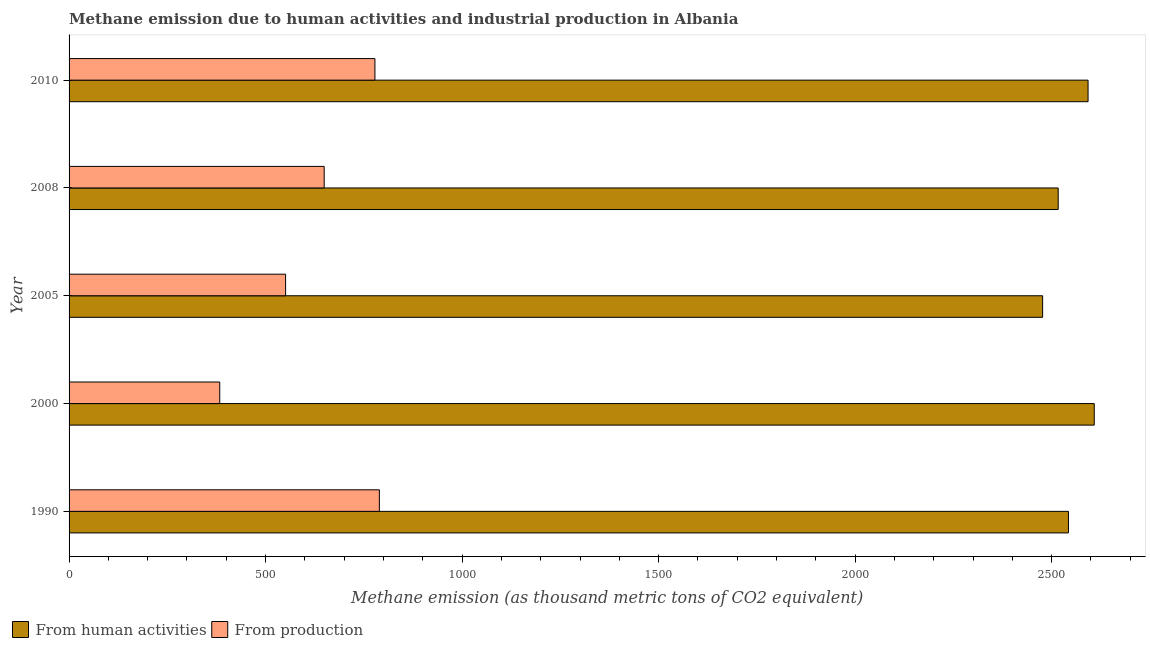How many groups of bars are there?
Give a very brief answer. 5. Are the number of bars on each tick of the Y-axis equal?
Ensure brevity in your answer.  Yes. What is the label of the 4th group of bars from the top?
Keep it short and to the point. 2000. What is the amount of emissions generated from industries in 2005?
Offer a terse response. 550.9. Across all years, what is the maximum amount of emissions from human activities?
Your answer should be very brief. 2608.4. Across all years, what is the minimum amount of emissions generated from industries?
Your response must be concise. 383.4. In which year was the amount of emissions from human activities maximum?
Make the answer very short. 2000. In which year was the amount of emissions generated from industries minimum?
Give a very brief answer. 2000. What is the total amount of emissions from human activities in the graph?
Your response must be concise. 1.27e+04. What is the difference between the amount of emissions from human activities in 2005 and that in 2010?
Provide a short and direct response. -115.6. What is the difference between the amount of emissions from human activities in 2005 and the amount of emissions generated from industries in 2010?
Make the answer very short. 1698.9. What is the average amount of emissions from human activities per year?
Ensure brevity in your answer.  2547.54. In the year 2008, what is the difference between the amount of emissions from human activities and amount of emissions generated from industries?
Your answer should be compact. 1867.6. What is the ratio of the amount of emissions from human activities in 2008 to that in 2010?
Give a very brief answer. 0.97. Is the amount of emissions generated from industries in 2005 less than that in 2008?
Your answer should be very brief. Yes. Is the difference between the amount of emissions generated from industries in 2005 and 2008 greater than the difference between the amount of emissions from human activities in 2005 and 2008?
Your answer should be compact. No. What is the difference between the highest and the second highest amount of emissions generated from industries?
Offer a very short reply. 11.3. What is the difference between the highest and the lowest amount of emissions generated from industries?
Provide a short and direct response. 406.1. In how many years, is the amount of emissions generated from industries greater than the average amount of emissions generated from industries taken over all years?
Offer a very short reply. 3. Is the sum of the amount of emissions from human activities in 2000 and 2008 greater than the maximum amount of emissions generated from industries across all years?
Your response must be concise. Yes. What does the 1st bar from the top in 2010 represents?
Your answer should be compact. From production. What does the 1st bar from the bottom in 1990 represents?
Provide a short and direct response. From human activities. Are all the bars in the graph horizontal?
Offer a terse response. Yes. What is the difference between two consecutive major ticks on the X-axis?
Give a very brief answer. 500. Are the values on the major ticks of X-axis written in scientific E-notation?
Ensure brevity in your answer.  No. How are the legend labels stacked?
Your answer should be compact. Horizontal. What is the title of the graph?
Ensure brevity in your answer.  Methane emission due to human activities and industrial production in Albania. Does "Crop" appear as one of the legend labels in the graph?
Your response must be concise. No. What is the label or title of the X-axis?
Your answer should be very brief. Methane emission (as thousand metric tons of CO2 equivalent). What is the label or title of the Y-axis?
Your response must be concise. Year. What is the Methane emission (as thousand metric tons of CO2 equivalent) in From human activities in 1990?
Provide a succinct answer. 2542.8. What is the Methane emission (as thousand metric tons of CO2 equivalent) in From production in 1990?
Make the answer very short. 789.5. What is the Methane emission (as thousand metric tons of CO2 equivalent) of From human activities in 2000?
Ensure brevity in your answer.  2608.4. What is the Methane emission (as thousand metric tons of CO2 equivalent) of From production in 2000?
Provide a succinct answer. 383.4. What is the Methane emission (as thousand metric tons of CO2 equivalent) of From human activities in 2005?
Make the answer very short. 2477.1. What is the Methane emission (as thousand metric tons of CO2 equivalent) in From production in 2005?
Provide a succinct answer. 550.9. What is the Methane emission (as thousand metric tons of CO2 equivalent) of From human activities in 2008?
Offer a terse response. 2516.7. What is the Methane emission (as thousand metric tons of CO2 equivalent) in From production in 2008?
Give a very brief answer. 649.1. What is the Methane emission (as thousand metric tons of CO2 equivalent) in From human activities in 2010?
Make the answer very short. 2592.7. What is the Methane emission (as thousand metric tons of CO2 equivalent) of From production in 2010?
Ensure brevity in your answer.  778.2. Across all years, what is the maximum Methane emission (as thousand metric tons of CO2 equivalent) in From human activities?
Your response must be concise. 2608.4. Across all years, what is the maximum Methane emission (as thousand metric tons of CO2 equivalent) in From production?
Provide a short and direct response. 789.5. Across all years, what is the minimum Methane emission (as thousand metric tons of CO2 equivalent) of From human activities?
Your answer should be very brief. 2477.1. Across all years, what is the minimum Methane emission (as thousand metric tons of CO2 equivalent) in From production?
Keep it short and to the point. 383.4. What is the total Methane emission (as thousand metric tons of CO2 equivalent) of From human activities in the graph?
Offer a very short reply. 1.27e+04. What is the total Methane emission (as thousand metric tons of CO2 equivalent) of From production in the graph?
Give a very brief answer. 3151.1. What is the difference between the Methane emission (as thousand metric tons of CO2 equivalent) of From human activities in 1990 and that in 2000?
Give a very brief answer. -65.6. What is the difference between the Methane emission (as thousand metric tons of CO2 equivalent) of From production in 1990 and that in 2000?
Provide a short and direct response. 406.1. What is the difference between the Methane emission (as thousand metric tons of CO2 equivalent) in From human activities in 1990 and that in 2005?
Your answer should be very brief. 65.7. What is the difference between the Methane emission (as thousand metric tons of CO2 equivalent) of From production in 1990 and that in 2005?
Your answer should be compact. 238.6. What is the difference between the Methane emission (as thousand metric tons of CO2 equivalent) of From human activities in 1990 and that in 2008?
Your answer should be compact. 26.1. What is the difference between the Methane emission (as thousand metric tons of CO2 equivalent) in From production in 1990 and that in 2008?
Make the answer very short. 140.4. What is the difference between the Methane emission (as thousand metric tons of CO2 equivalent) of From human activities in 1990 and that in 2010?
Offer a terse response. -49.9. What is the difference between the Methane emission (as thousand metric tons of CO2 equivalent) in From human activities in 2000 and that in 2005?
Offer a terse response. 131.3. What is the difference between the Methane emission (as thousand metric tons of CO2 equivalent) in From production in 2000 and that in 2005?
Offer a very short reply. -167.5. What is the difference between the Methane emission (as thousand metric tons of CO2 equivalent) of From human activities in 2000 and that in 2008?
Offer a very short reply. 91.7. What is the difference between the Methane emission (as thousand metric tons of CO2 equivalent) in From production in 2000 and that in 2008?
Keep it short and to the point. -265.7. What is the difference between the Methane emission (as thousand metric tons of CO2 equivalent) in From production in 2000 and that in 2010?
Offer a terse response. -394.8. What is the difference between the Methane emission (as thousand metric tons of CO2 equivalent) in From human activities in 2005 and that in 2008?
Give a very brief answer. -39.6. What is the difference between the Methane emission (as thousand metric tons of CO2 equivalent) in From production in 2005 and that in 2008?
Your answer should be compact. -98.2. What is the difference between the Methane emission (as thousand metric tons of CO2 equivalent) in From human activities in 2005 and that in 2010?
Offer a terse response. -115.6. What is the difference between the Methane emission (as thousand metric tons of CO2 equivalent) in From production in 2005 and that in 2010?
Ensure brevity in your answer.  -227.3. What is the difference between the Methane emission (as thousand metric tons of CO2 equivalent) in From human activities in 2008 and that in 2010?
Give a very brief answer. -76. What is the difference between the Methane emission (as thousand metric tons of CO2 equivalent) of From production in 2008 and that in 2010?
Ensure brevity in your answer.  -129.1. What is the difference between the Methane emission (as thousand metric tons of CO2 equivalent) of From human activities in 1990 and the Methane emission (as thousand metric tons of CO2 equivalent) of From production in 2000?
Your answer should be compact. 2159.4. What is the difference between the Methane emission (as thousand metric tons of CO2 equivalent) in From human activities in 1990 and the Methane emission (as thousand metric tons of CO2 equivalent) in From production in 2005?
Provide a succinct answer. 1991.9. What is the difference between the Methane emission (as thousand metric tons of CO2 equivalent) of From human activities in 1990 and the Methane emission (as thousand metric tons of CO2 equivalent) of From production in 2008?
Your answer should be very brief. 1893.7. What is the difference between the Methane emission (as thousand metric tons of CO2 equivalent) of From human activities in 1990 and the Methane emission (as thousand metric tons of CO2 equivalent) of From production in 2010?
Provide a succinct answer. 1764.6. What is the difference between the Methane emission (as thousand metric tons of CO2 equivalent) in From human activities in 2000 and the Methane emission (as thousand metric tons of CO2 equivalent) in From production in 2005?
Your response must be concise. 2057.5. What is the difference between the Methane emission (as thousand metric tons of CO2 equivalent) in From human activities in 2000 and the Methane emission (as thousand metric tons of CO2 equivalent) in From production in 2008?
Ensure brevity in your answer.  1959.3. What is the difference between the Methane emission (as thousand metric tons of CO2 equivalent) of From human activities in 2000 and the Methane emission (as thousand metric tons of CO2 equivalent) of From production in 2010?
Provide a short and direct response. 1830.2. What is the difference between the Methane emission (as thousand metric tons of CO2 equivalent) in From human activities in 2005 and the Methane emission (as thousand metric tons of CO2 equivalent) in From production in 2008?
Offer a terse response. 1828. What is the difference between the Methane emission (as thousand metric tons of CO2 equivalent) of From human activities in 2005 and the Methane emission (as thousand metric tons of CO2 equivalent) of From production in 2010?
Your answer should be very brief. 1698.9. What is the difference between the Methane emission (as thousand metric tons of CO2 equivalent) of From human activities in 2008 and the Methane emission (as thousand metric tons of CO2 equivalent) of From production in 2010?
Give a very brief answer. 1738.5. What is the average Methane emission (as thousand metric tons of CO2 equivalent) of From human activities per year?
Your answer should be compact. 2547.54. What is the average Methane emission (as thousand metric tons of CO2 equivalent) of From production per year?
Offer a terse response. 630.22. In the year 1990, what is the difference between the Methane emission (as thousand metric tons of CO2 equivalent) of From human activities and Methane emission (as thousand metric tons of CO2 equivalent) of From production?
Give a very brief answer. 1753.3. In the year 2000, what is the difference between the Methane emission (as thousand metric tons of CO2 equivalent) in From human activities and Methane emission (as thousand metric tons of CO2 equivalent) in From production?
Offer a very short reply. 2225. In the year 2005, what is the difference between the Methane emission (as thousand metric tons of CO2 equivalent) of From human activities and Methane emission (as thousand metric tons of CO2 equivalent) of From production?
Provide a short and direct response. 1926.2. In the year 2008, what is the difference between the Methane emission (as thousand metric tons of CO2 equivalent) in From human activities and Methane emission (as thousand metric tons of CO2 equivalent) in From production?
Give a very brief answer. 1867.6. In the year 2010, what is the difference between the Methane emission (as thousand metric tons of CO2 equivalent) of From human activities and Methane emission (as thousand metric tons of CO2 equivalent) of From production?
Ensure brevity in your answer.  1814.5. What is the ratio of the Methane emission (as thousand metric tons of CO2 equivalent) in From human activities in 1990 to that in 2000?
Your response must be concise. 0.97. What is the ratio of the Methane emission (as thousand metric tons of CO2 equivalent) of From production in 1990 to that in 2000?
Make the answer very short. 2.06. What is the ratio of the Methane emission (as thousand metric tons of CO2 equivalent) in From human activities in 1990 to that in 2005?
Offer a very short reply. 1.03. What is the ratio of the Methane emission (as thousand metric tons of CO2 equivalent) of From production in 1990 to that in 2005?
Your response must be concise. 1.43. What is the ratio of the Methane emission (as thousand metric tons of CO2 equivalent) of From human activities in 1990 to that in 2008?
Your response must be concise. 1.01. What is the ratio of the Methane emission (as thousand metric tons of CO2 equivalent) in From production in 1990 to that in 2008?
Provide a succinct answer. 1.22. What is the ratio of the Methane emission (as thousand metric tons of CO2 equivalent) in From human activities in 1990 to that in 2010?
Your answer should be very brief. 0.98. What is the ratio of the Methane emission (as thousand metric tons of CO2 equivalent) in From production in 1990 to that in 2010?
Your response must be concise. 1.01. What is the ratio of the Methane emission (as thousand metric tons of CO2 equivalent) in From human activities in 2000 to that in 2005?
Your response must be concise. 1.05. What is the ratio of the Methane emission (as thousand metric tons of CO2 equivalent) of From production in 2000 to that in 2005?
Provide a short and direct response. 0.7. What is the ratio of the Methane emission (as thousand metric tons of CO2 equivalent) in From human activities in 2000 to that in 2008?
Offer a terse response. 1.04. What is the ratio of the Methane emission (as thousand metric tons of CO2 equivalent) of From production in 2000 to that in 2008?
Your answer should be compact. 0.59. What is the ratio of the Methane emission (as thousand metric tons of CO2 equivalent) in From human activities in 2000 to that in 2010?
Your answer should be very brief. 1.01. What is the ratio of the Methane emission (as thousand metric tons of CO2 equivalent) of From production in 2000 to that in 2010?
Make the answer very short. 0.49. What is the ratio of the Methane emission (as thousand metric tons of CO2 equivalent) in From human activities in 2005 to that in 2008?
Your answer should be very brief. 0.98. What is the ratio of the Methane emission (as thousand metric tons of CO2 equivalent) in From production in 2005 to that in 2008?
Make the answer very short. 0.85. What is the ratio of the Methane emission (as thousand metric tons of CO2 equivalent) of From human activities in 2005 to that in 2010?
Make the answer very short. 0.96. What is the ratio of the Methane emission (as thousand metric tons of CO2 equivalent) of From production in 2005 to that in 2010?
Give a very brief answer. 0.71. What is the ratio of the Methane emission (as thousand metric tons of CO2 equivalent) in From human activities in 2008 to that in 2010?
Ensure brevity in your answer.  0.97. What is the ratio of the Methane emission (as thousand metric tons of CO2 equivalent) of From production in 2008 to that in 2010?
Your answer should be compact. 0.83. What is the difference between the highest and the second highest Methane emission (as thousand metric tons of CO2 equivalent) of From human activities?
Make the answer very short. 15.7. What is the difference between the highest and the lowest Methane emission (as thousand metric tons of CO2 equivalent) of From human activities?
Ensure brevity in your answer.  131.3. What is the difference between the highest and the lowest Methane emission (as thousand metric tons of CO2 equivalent) in From production?
Your answer should be very brief. 406.1. 